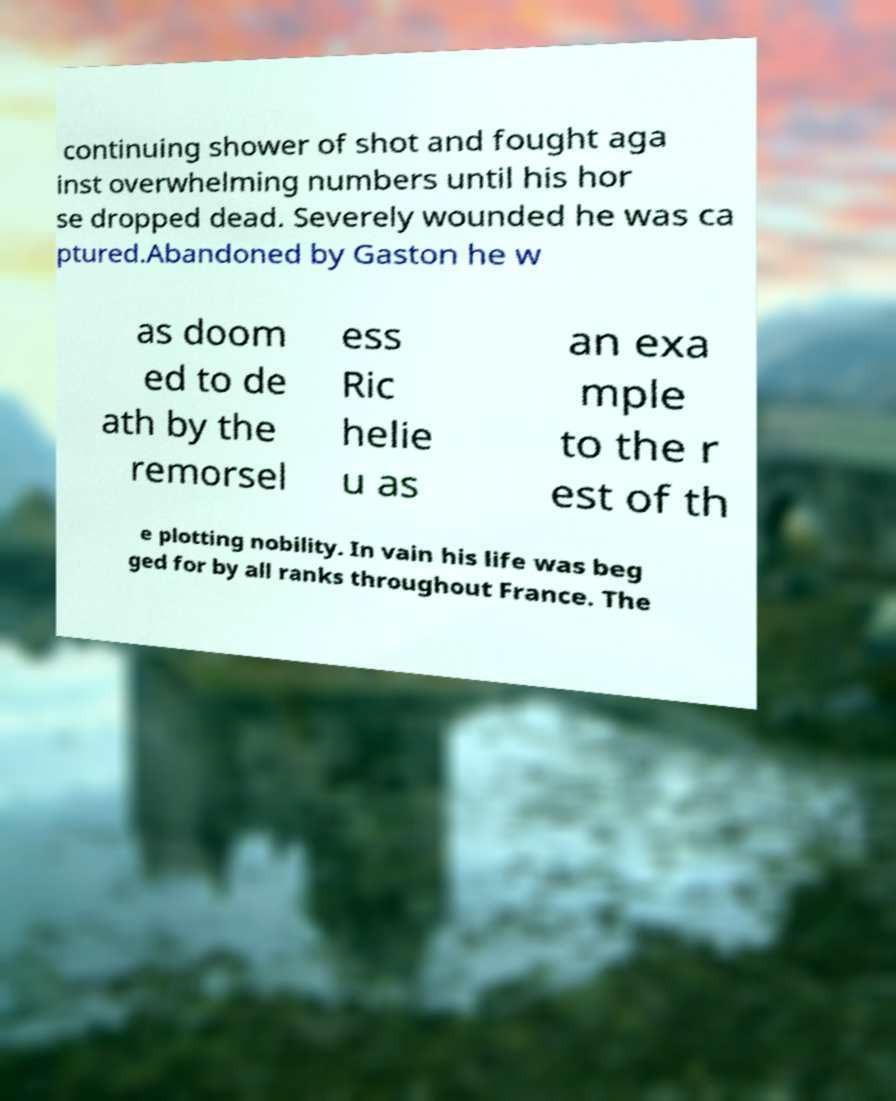Could you extract and type out the text from this image? continuing shower of shot and fought aga inst overwhelming numbers until his hor se dropped dead. Severely wounded he was ca ptured.Abandoned by Gaston he w as doom ed to de ath by the remorsel ess Ric helie u as an exa mple to the r est of th e plotting nobility. In vain his life was beg ged for by all ranks throughout France. The 